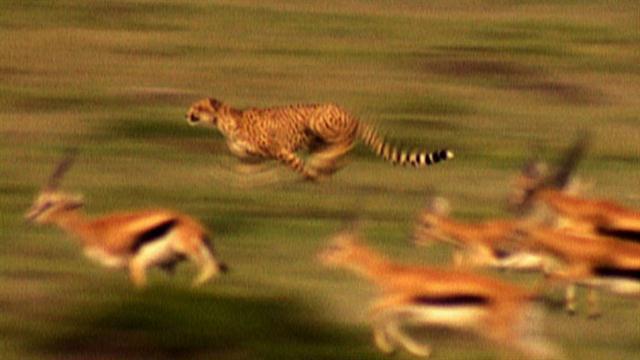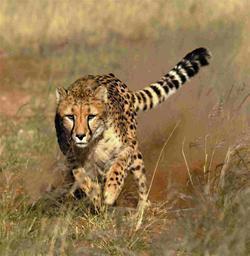The first image is the image on the left, the second image is the image on the right. Evaluate the accuracy of this statement regarding the images: "In one image, a jaguar is hunting one single prey.". Is it true? Answer yes or no. No. The first image is the image on the left, the second image is the image on the right. Assess this claim about the two images: "There is a single cheetah pursuing a prey in the right image.". Correct or not? Answer yes or no. No. 